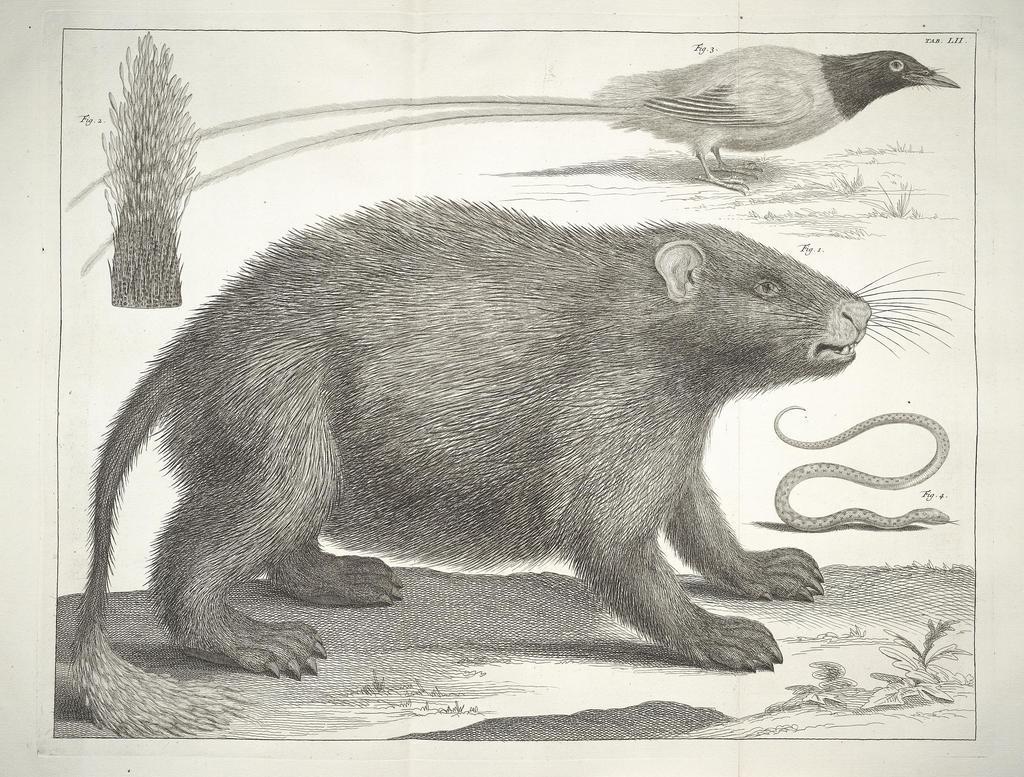Describe this image in one or two sentences. In the center of the image there are different animal species. 